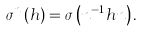Convert formula to latex. <formula><loc_0><loc_0><loc_500><loc_500>\sigma ^ { n } \left ( h \right ) = \sigma \left ( n ^ { - 1 } h n \right ) .</formula> 